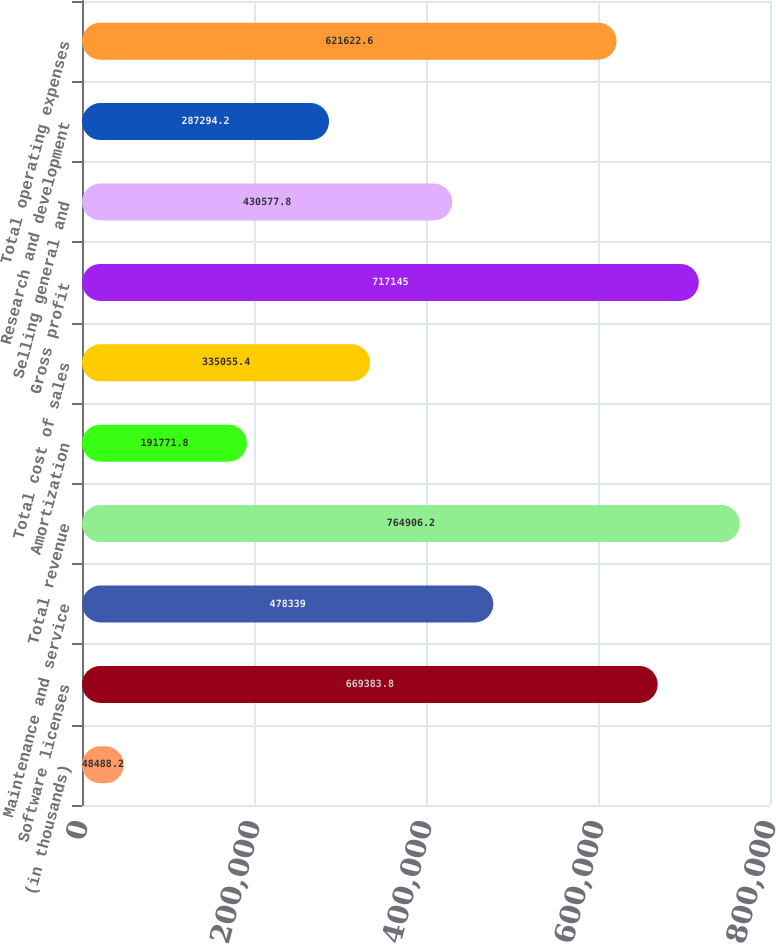Convert chart. <chart><loc_0><loc_0><loc_500><loc_500><bar_chart><fcel>(in thousands)<fcel>Software licenses<fcel>Maintenance and service<fcel>Total revenue<fcel>Amortization<fcel>Total cost of sales<fcel>Gross profit<fcel>Selling general and<fcel>Research and development<fcel>Total operating expenses<nl><fcel>48488.2<fcel>669384<fcel>478339<fcel>764906<fcel>191772<fcel>335055<fcel>717145<fcel>430578<fcel>287294<fcel>621623<nl></chart> 